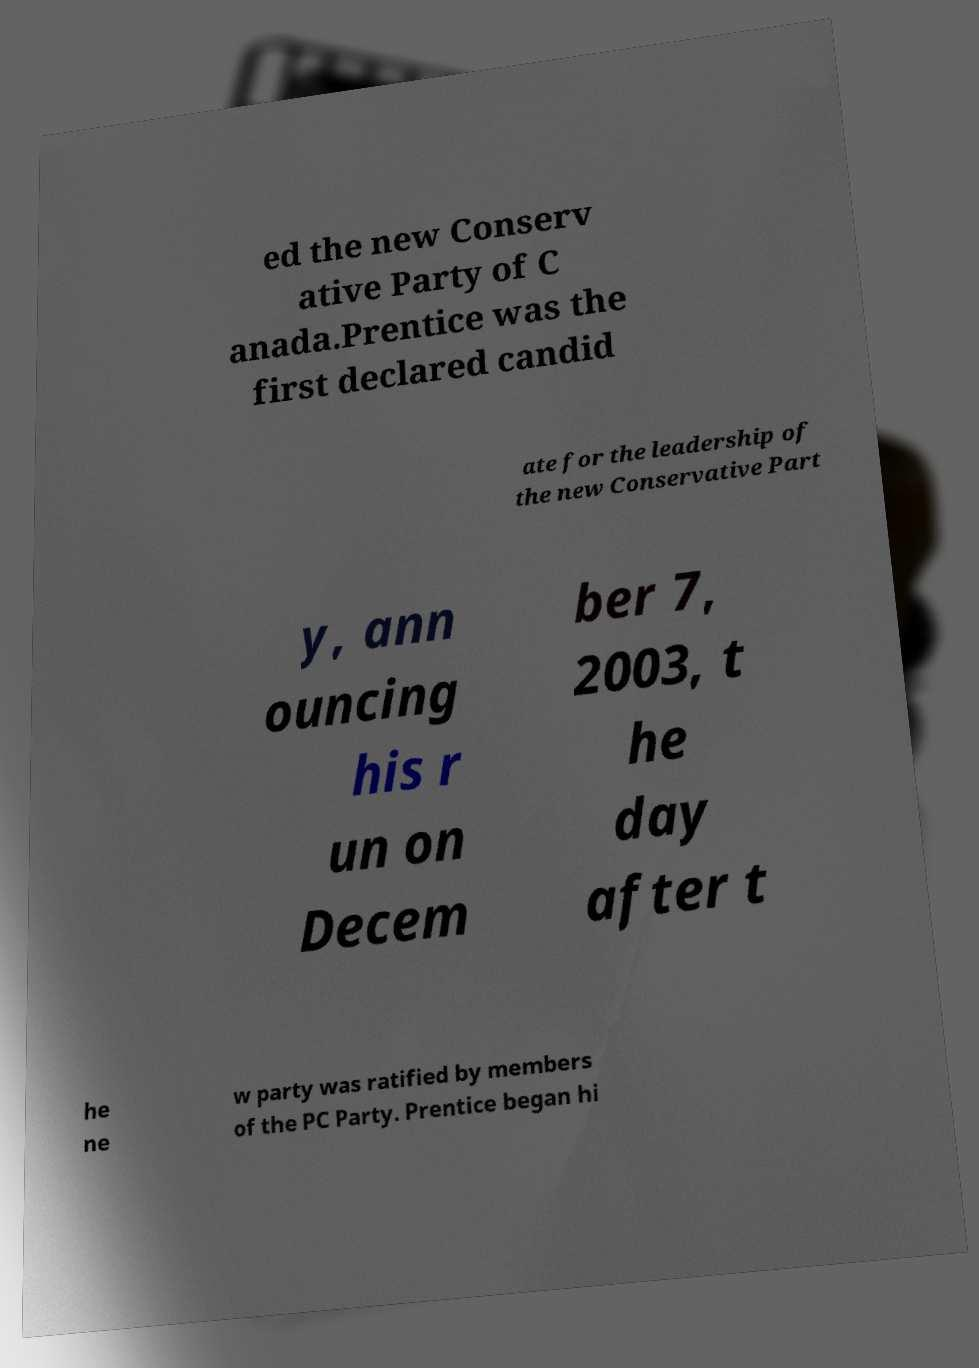Please read and relay the text visible in this image. What does it say? ed the new Conserv ative Party of C anada.Prentice was the first declared candid ate for the leadership of the new Conservative Part y, ann ouncing his r un on Decem ber 7, 2003, t he day after t he ne w party was ratified by members of the PC Party. Prentice began hi 